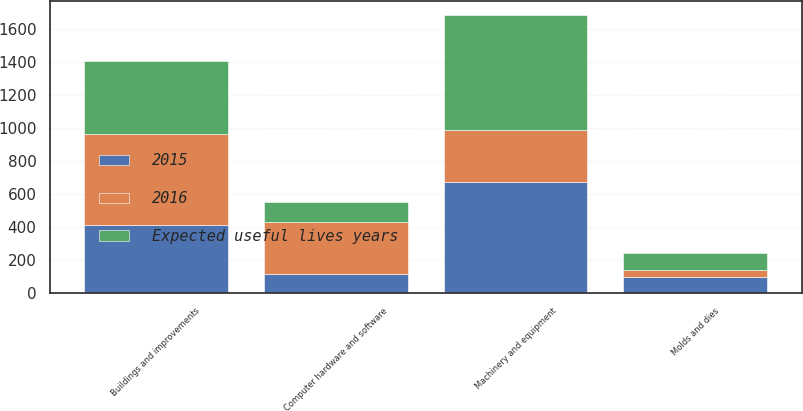Convert chart to OTSL. <chart><loc_0><loc_0><loc_500><loc_500><stacked_bar_chart><ecel><fcel>Buildings and improvements<fcel>Machinery and equipment<fcel>Molds and dies<fcel>Computer hardware and software<nl><fcel>2016<fcel>550<fcel>310<fcel>47<fcel>310<nl><fcel>Expected useful lives years<fcel>443.3<fcel>698.5<fcel>98.3<fcel>121.9<nl><fcel>2015<fcel>412.8<fcel>674.8<fcel>94.4<fcel>118.3<nl></chart> 